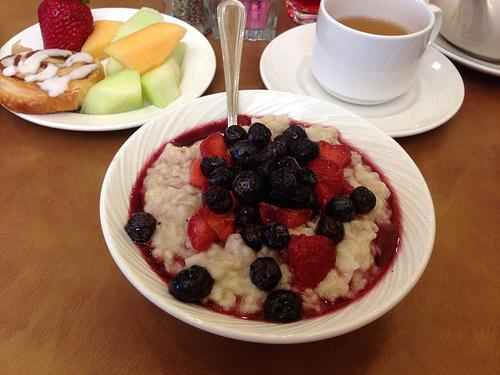Write a caption for the image that could be used in a food blog. "Breakfast Bliss: A Bowl of Berry-infused Oatmeal Paired with Fresh Fruits and Pastry, Accompanied by a Steaming Cup of Tea." Imagine the image is being used for a commercial, and write a catchy jingle. "Start your day the right way, with a bowl of fruity oatmeal, melons, and pastry, sipping on hot tea all the way!" Describe the image as if you were speaking to a friend. Hey, there's this picture of a breakfast spread with a mouthwatering oatmeal topped with strawberries and blueberries, as well as a plate of melons, a pastry, and a warm cup of tea. Explain the image in the form of a recipe. Start with a bowl of oatmeal, add strawberries, blueberries, and blackberries. Serve it with a side of sliced melons, a pastry, and a cup of hot tea to enjoy a delightful breakfast. In a casual tone, explain what someone might experience in this picture. You can see a delicious breakfast scene with a bowl of oatmeal topped with berries, some fruits and pastry on a plate, and tea in a white cup. Write a haiku inspired by the image. Tea waits patiently. With an artistic lens, describe the image's visual elements. A vibrant tableau of hearty oatmeal framed by vivid berries, accompanied by the soft, muted tones of melon slices and a flaky pastry, contrasted by the pristine white of a tea-filled cup. List three items that are prominently displayed in the photograph. Bowl of oatmeal with fruit, plate of melons and pastry, white coffee cup and saucer. Provide a brief description of the focal point of the image. A bowl of oatmeal with strawberries, blueberries, and blackberries is the center of a breakfast spread. Summarize the scene in one sentence. A cozy, inviting breakfast setup with oatmeal topped with fruit, a plate of melons and pastry, and a warm cup of tea. 